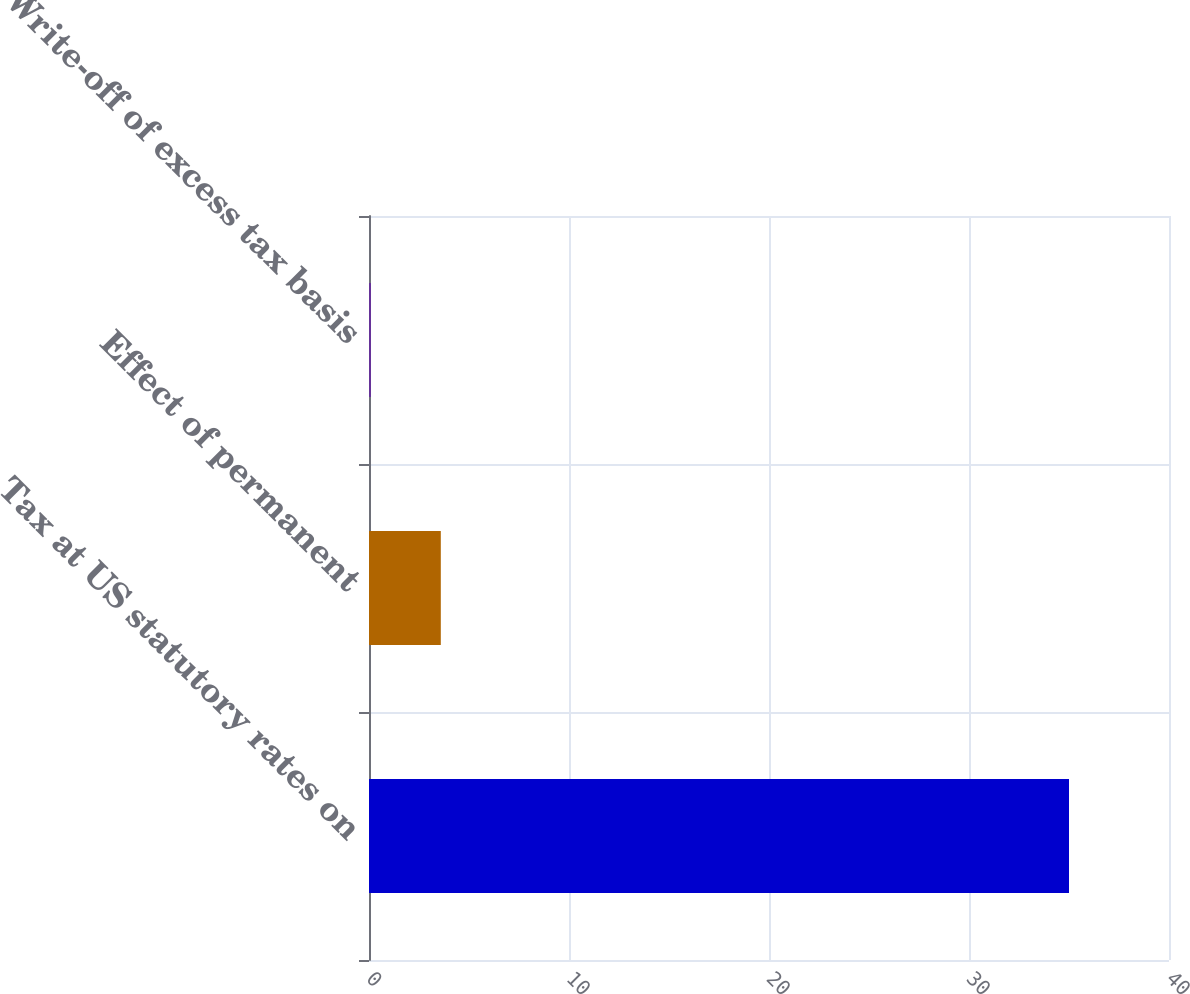Convert chart to OTSL. <chart><loc_0><loc_0><loc_500><loc_500><bar_chart><fcel>Tax at US statutory rates on<fcel>Effect of permanent<fcel>Write-off of excess tax basis<nl><fcel>35<fcel>3.59<fcel>0.1<nl></chart> 